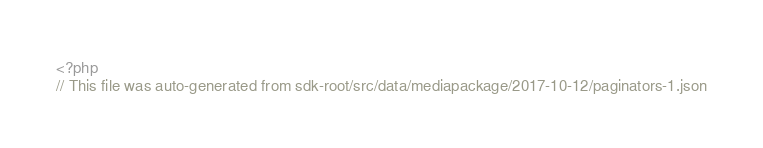<code> <loc_0><loc_0><loc_500><loc_500><_PHP_><?php
// This file was auto-generated from sdk-root/src/data/mediapackage/2017-10-12/paginators-1.json</code> 